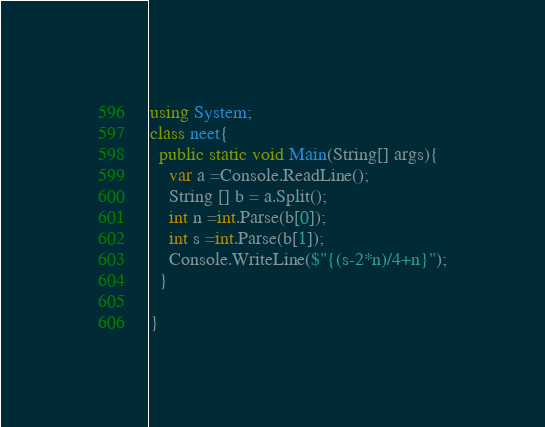<code> <loc_0><loc_0><loc_500><loc_500><_C#_>using System;
class neet{
  public static void Main(String[] args){
    var a =Console.ReadLine();
    String [] b = a.Split();
    int n =int.Parse(b[0]);
    int s =int.Parse(b[1]);
    Console.WriteLine($"{(s-2*n)/4+n}");
  }

}</code> 